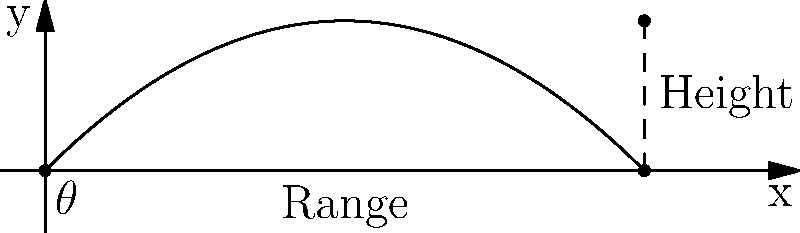In the Metal Gear Solid universe, Snake needs to launch a cardboard box for maximum concealment. Given that the initial velocity of the box is 10 m/s, what angle $\theta$ should Snake launch the box at to achieve the maximum range, and what will be the maximum height reached by the box? To solve this problem, we'll follow these steps:

1. Determine the optimal angle for maximum range:
   The angle that gives maximum range in projectile motion is 45°. This is because it provides the best balance between horizontal and vertical components of velocity.

2. Calculate the maximum range:
   The range R is given by the formula: $R = \frac{v_0^2 \sin(2\theta)}{g}$
   Where $v_0 = 10$ m/s, $\theta = 45°$, and $g = 9.8$ m/s²
   $R = \frac{10^2 \sin(2 \cdot 45°)}{9.8} = \frac{100 \cdot 1}{9.8} \approx 10.20$ m

3. Calculate the maximum height:
   The maximum height H is given by the formula: $H = \frac{v_0^2 \sin^2(\theta)}{2g}$
   $H = \frac{10^2 \sin^2(45°)}{2 \cdot 9.8} = \frac{100 \cdot 0.5}{19.6} \approx 2.55$ m

Therefore, Snake should launch the cardboard box at a 45° angle to achieve the maximum range of about 10.20 meters, and the box will reach a maximum height of approximately 2.55 meters.
Answer: $\theta = 45°$, Maximum height ≈ 2.55 m 